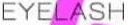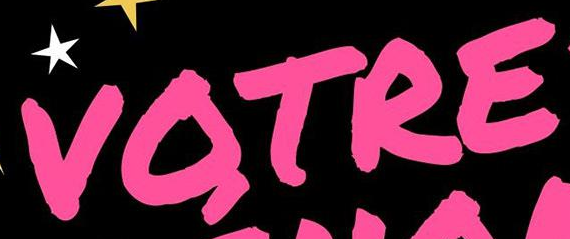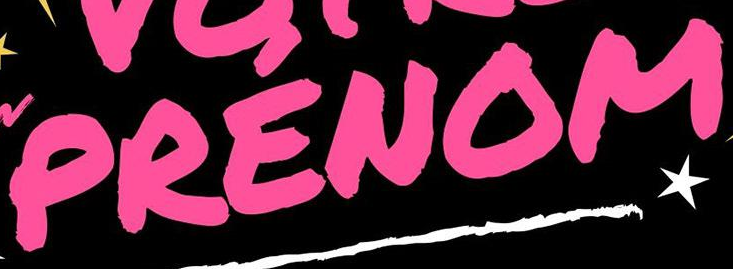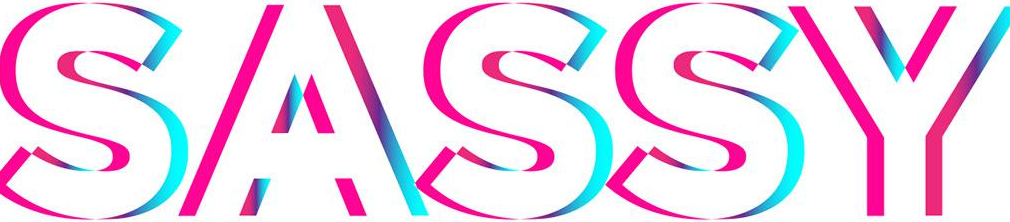What text appears in these images from left to right, separated by a semicolon? EYELASH; VOTRE; PRENOM; SASSY 